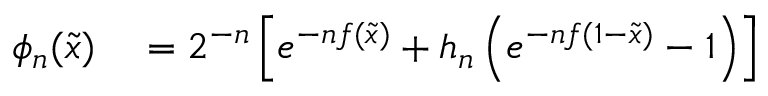<formula> <loc_0><loc_0><loc_500><loc_500>\begin{array} { r l } { \phi _ { n } ( { \tilde { x } } ) } & = 2 ^ { - n } \left [ e ^ { - n f ( { \tilde { x } } ) } + h _ { n } \left ( e ^ { - n f ( 1 - { \tilde { x } } ) } - 1 \right ) \right ] } \end{array}</formula> 